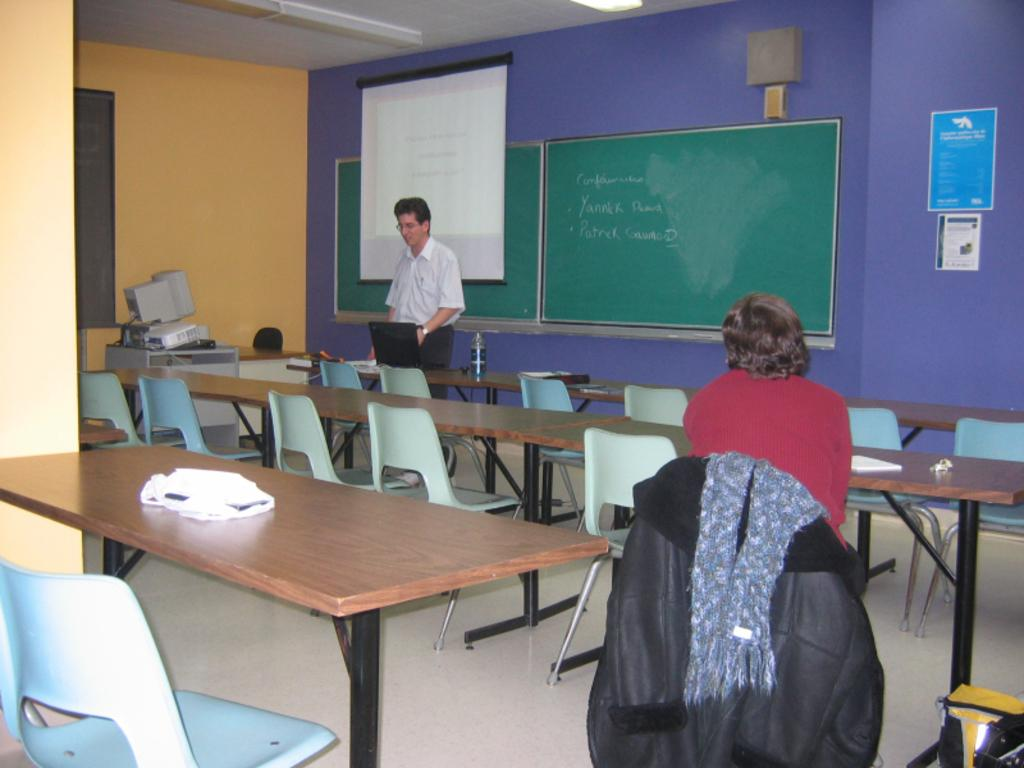How many people are in the image? There are two people in the image. What is the position of one of the people? One person is sitting on a chair. What is the other person doing in the image? The other person is standing near a board. What type of pen is the person holding in the image? There is no pen present in the image. Is there a bomb visible in the image? No, there is no bomb visible in the image. 